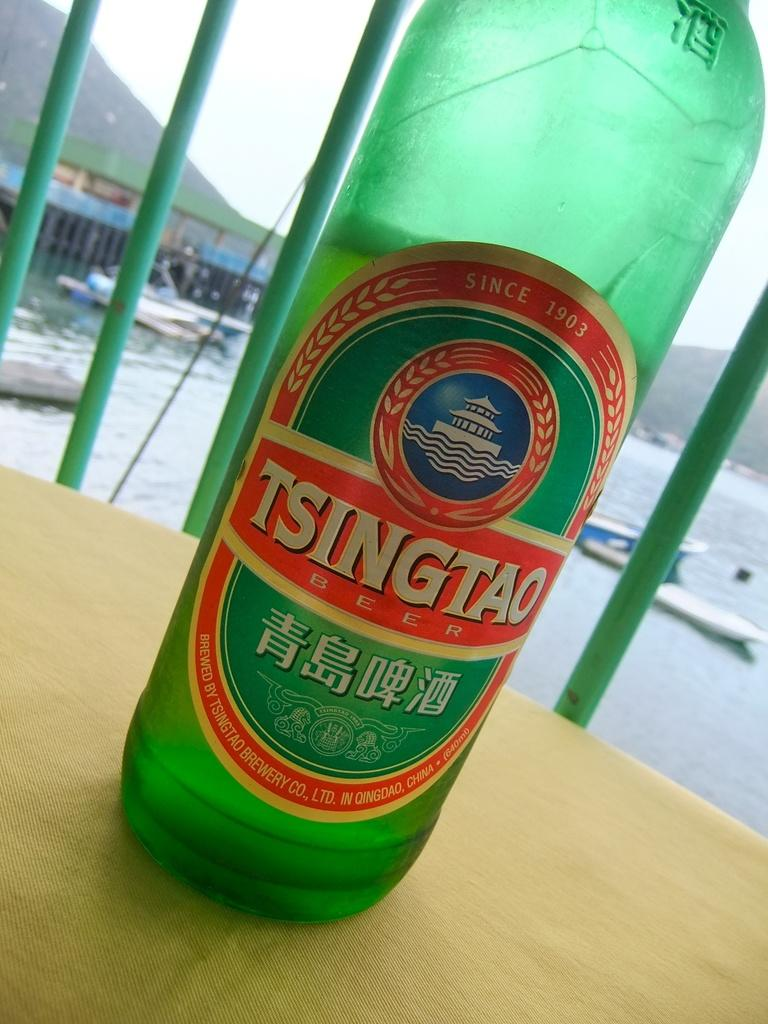<image>
Give a short and clear explanation of the subsequent image. Tsingtao Beer Bottle that is standing on top of a table. 